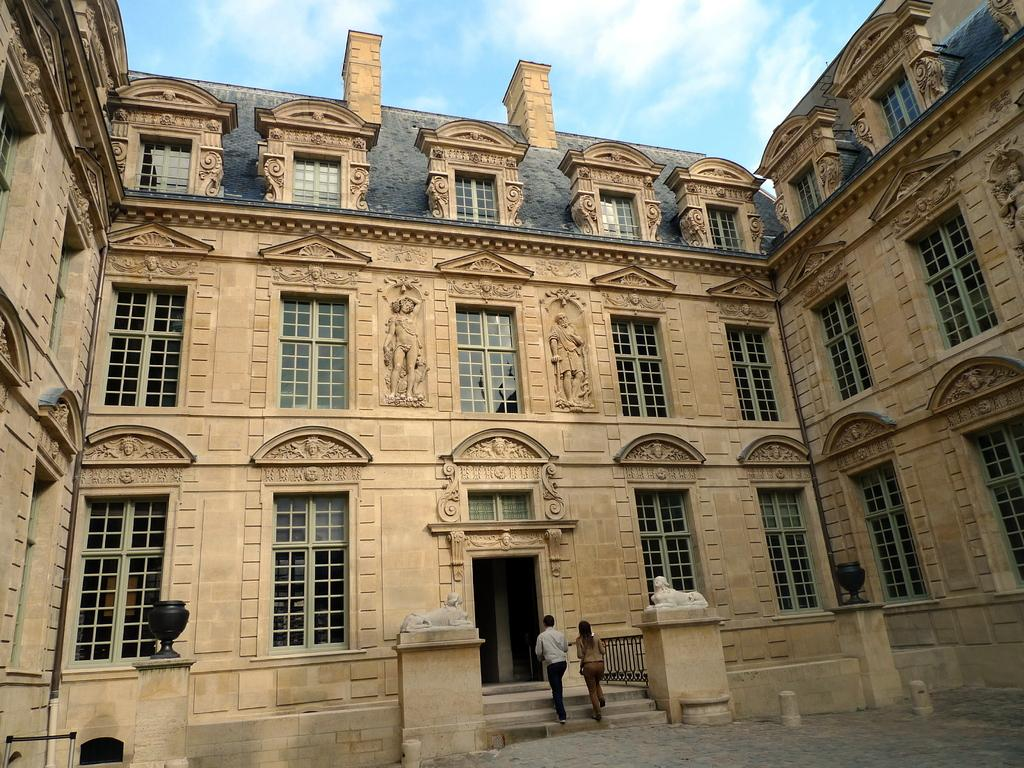What is the main structure in the image? There is a huge building in the image. What can be observed about the building's design? The building has many windows and carvings on its walls. What are the people in the image doing? Two people are walking into the building. What sense is being stimulated by the door in the image? There is no door mentioned in the image; it only refers to a building with people walking into it. 